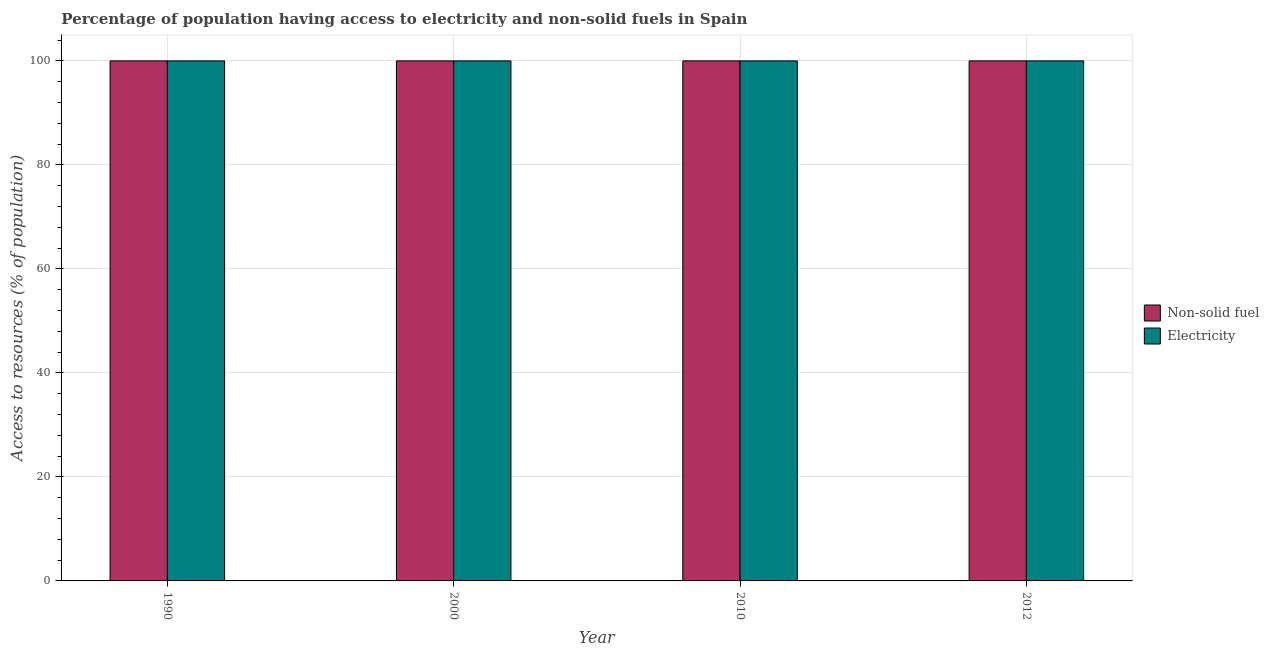How many different coloured bars are there?
Offer a terse response. 2. Are the number of bars per tick equal to the number of legend labels?
Give a very brief answer. Yes. In how many cases, is the number of bars for a given year not equal to the number of legend labels?
Your answer should be very brief. 0. What is the percentage of population having access to electricity in 2012?
Provide a succinct answer. 100. Across all years, what is the maximum percentage of population having access to non-solid fuel?
Your answer should be compact. 100. Across all years, what is the minimum percentage of population having access to non-solid fuel?
Make the answer very short. 100. What is the total percentage of population having access to non-solid fuel in the graph?
Your answer should be very brief. 400. What is the difference between the percentage of population having access to non-solid fuel in 1990 and the percentage of population having access to electricity in 2000?
Offer a very short reply. 0. In the year 2000, what is the difference between the percentage of population having access to electricity and percentage of population having access to non-solid fuel?
Offer a very short reply. 0. What is the difference between the highest and the second highest percentage of population having access to non-solid fuel?
Give a very brief answer. 0. What is the difference between the highest and the lowest percentage of population having access to electricity?
Give a very brief answer. 0. In how many years, is the percentage of population having access to non-solid fuel greater than the average percentage of population having access to non-solid fuel taken over all years?
Make the answer very short. 0. Is the sum of the percentage of population having access to non-solid fuel in 2000 and 2012 greater than the maximum percentage of population having access to electricity across all years?
Give a very brief answer. Yes. What does the 1st bar from the left in 1990 represents?
Your response must be concise. Non-solid fuel. What does the 1st bar from the right in 1990 represents?
Ensure brevity in your answer.  Electricity. Are all the bars in the graph horizontal?
Ensure brevity in your answer.  No. Are the values on the major ticks of Y-axis written in scientific E-notation?
Offer a terse response. No. Does the graph contain any zero values?
Your response must be concise. No. How many legend labels are there?
Your answer should be compact. 2. What is the title of the graph?
Ensure brevity in your answer.  Percentage of population having access to electricity and non-solid fuels in Spain. Does "By country of asylum" appear as one of the legend labels in the graph?
Give a very brief answer. No. What is the label or title of the X-axis?
Give a very brief answer. Year. What is the label or title of the Y-axis?
Your response must be concise. Access to resources (% of population). What is the Access to resources (% of population) of Non-solid fuel in 1990?
Your response must be concise. 100. What is the Access to resources (% of population) in Non-solid fuel in 2010?
Provide a succinct answer. 100. Across all years, what is the maximum Access to resources (% of population) of Electricity?
Offer a terse response. 100. Across all years, what is the minimum Access to resources (% of population) in Non-solid fuel?
Your response must be concise. 100. Across all years, what is the minimum Access to resources (% of population) in Electricity?
Give a very brief answer. 100. What is the difference between the Access to resources (% of population) in Non-solid fuel in 1990 and that in 2010?
Provide a short and direct response. 0. What is the difference between the Access to resources (% of population) of Electricity in 1990 and that in 2010?
Offer a very short reply. 0. What is the difference between the Access to resources (% of population) of Non-solid fuel in 2000 and that in 2010?
Offer a very short reply. 0. What is the difference between the Access to resources (% of population) in Electricity in 2000 and that in 2012?
Your answer should be very brief. 0. What is the difference between the Access to resources (% of population) of Non-solid fuel in 1990 and the Access to resources (% of population) of Electricity in 2000?
Offer a very short reply. 0. What is the difference between the Access to resources (% of population) in Non-solid fuel in 1990 and the Access to resources (% of population) in Electricity in 2012?
Offer a very short reply. 0. What is the difference between the Access to resources (% of population) in Non-solid fuel in 2000 and the Access to resources (% of population) in Electricity in 2012?
Provide a short and direct response. 0. What is the average Access to resources (% of population) of Electricity per year?
Make the answer very short. 100. In the year 2000, what is the difference between the Access to resources (% of population) of Non-solid fuel and Access to resources (% of population) of Electricity?
Offer a terse response. 0. In the year 2010, what is the difference between the Access to resources (% of population) in Non-solid fuel and Access to resources (% of population) in Electricity?
Offer a terse response. 0. What is the ratio of the Access to resources (% of population) of Non-solid fuel in 1990 to that in 2000?
Offer a very short reply. 1. What is the ratio of the Access to resources (% of population) in Non-solid fuel in 1990 to that in 2012?
Your response must be concise. 1. What is the ratio of the Access to resources (% of population) in Electricity in 1990 to that in 2012?
Keep it short and to the point. 1. What is the ratio of the Access to resources (% of population) in Electricity in 2000 to that in 2010?
Your answer should be very brief. 1. What is the ratio of the Access to resources (% of population) in Non-solid fuel in 2000 to that in 2012?
Your answer should be very brief. 1. What is the ratio of the Access to resources (% of population) of Electricity in 2000 to that in 2012?
Your answer should be very brief. 1. What is the ratio of the Access to resources (% of population) of Electricity in 2010 to that in 2012?
Ensure brevity in your answer.  1. What is the difference between the highest and the second highest Access to resources (% of population) of Non-solid fuel?
Offer a very short reply. 0. What is the difference between the highest and the lowest Access to resources (% of population) in Electricity?
Provide a succinct answer. 0. 